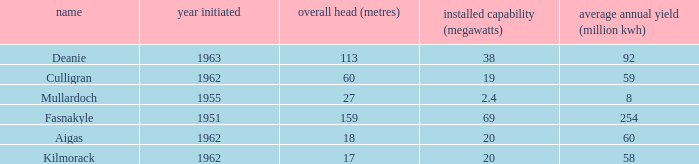What is the Average annual output for Culligran power station with an Installed capacity less than 19? None. 